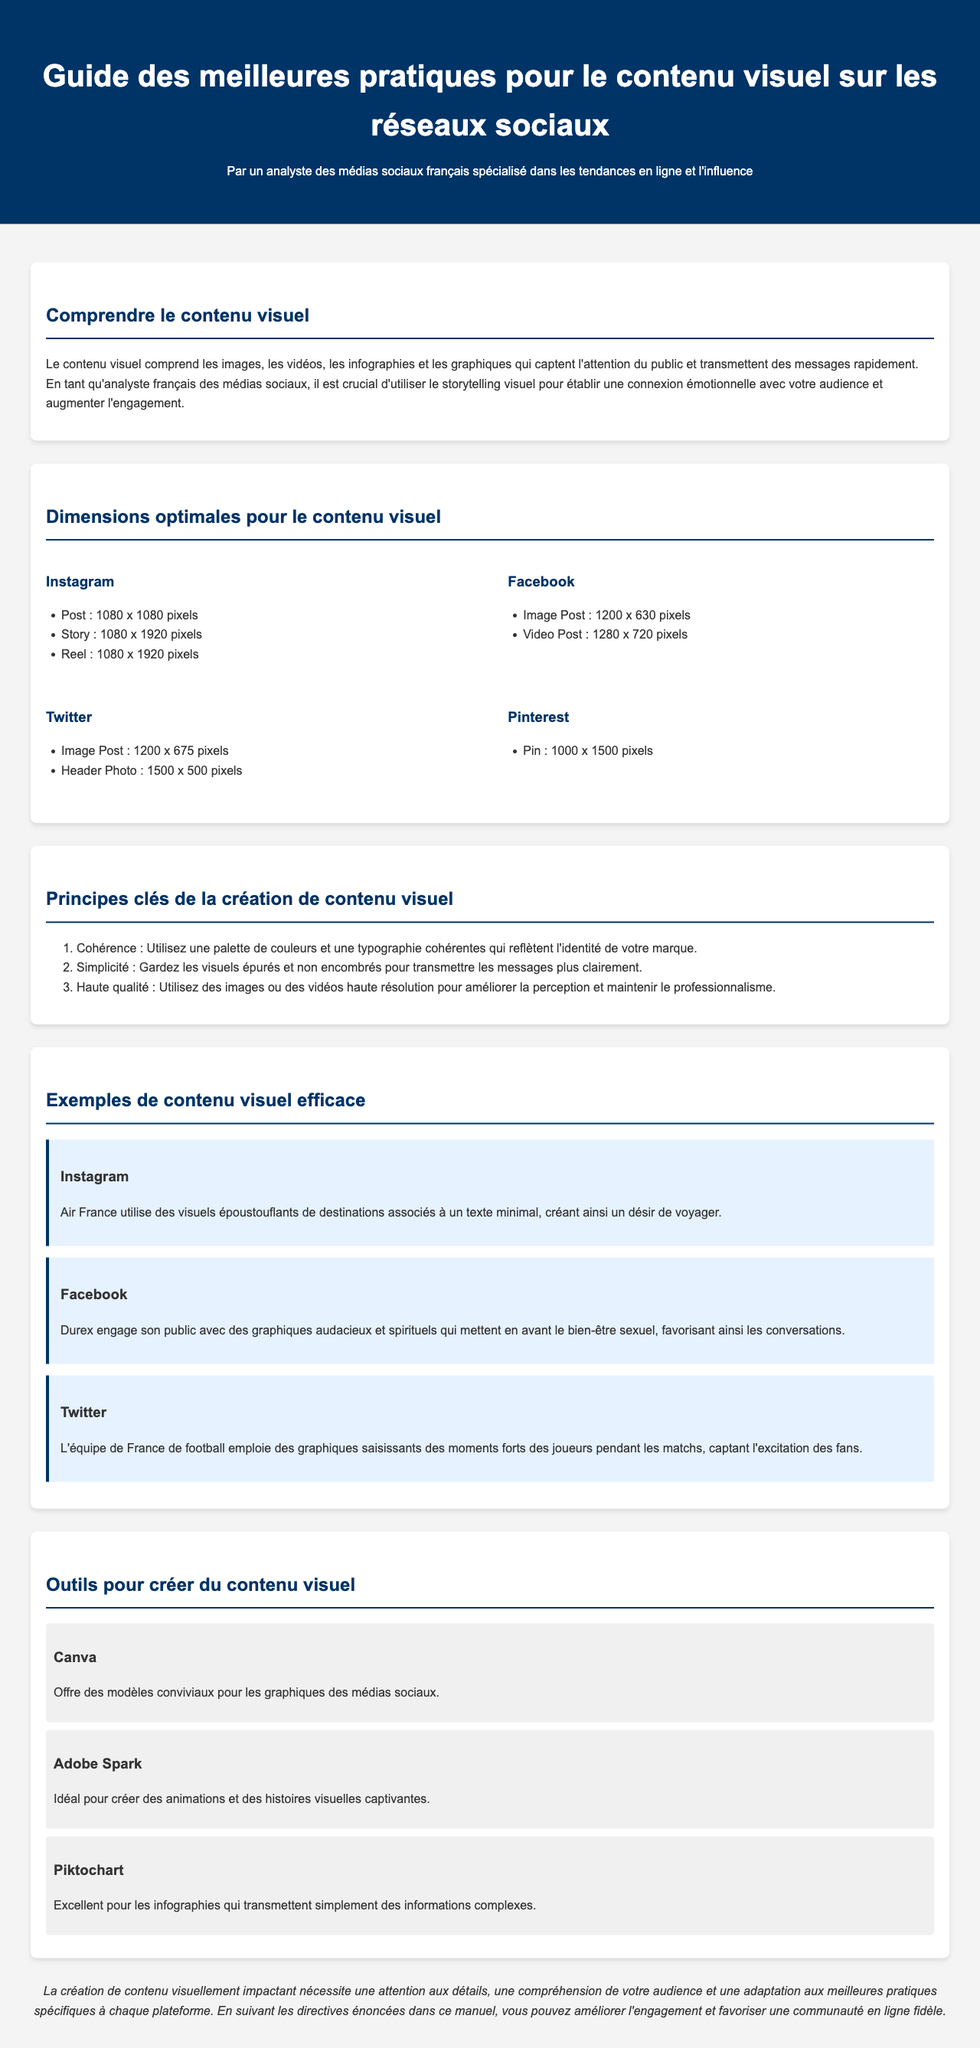What are the dimensions for an Instagram post? The dimensions for an Instagram post are specified as 1080 x 1080 pixels.
Answer: 1080 x 1080 pixels What is a key principle of creating visual content? One key principle mentioned is maintaining simplicity by keeping visuals clean and uncluttered.
Answer: Simplicité Which platform requires a header photo size of 1500 x 500 pixels? The document states that Twitter requires a header photo size of 1500 x 500 pixels.
Answer: Twitter What tool is ideal for creating animations? The document identifies Adobe Spark as the tool ideal for creating animations.
Answer: Adobe Spark Which company uses stunning visuals of destinations on Instagram? The document notes that Air France uses stunning visuals of destinations.
Answer: Air France What is the effective dimension for a Pinterest Pin? The effective dimension for a Pinterest Pin is 1000 x 1500 pixels.
Answer: 1000 x 1500 pixels What content type does Piktochart excel at creating? The document states that Piktochart is excellent for infographics.
Answer: Infographies What is the title of this guide? The title of the guide as stated in the document is "Guide des meilleures pratiques pour le contenu visuel sur les réseaux sociaux".
Answer: Guide des meilleures pratiques pour le contenu visuel sur les réseaux sociaux 